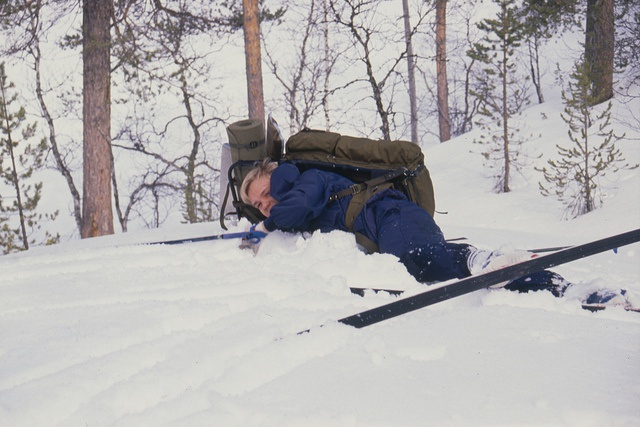Describe the objects in this image and their specific colors. I can see people in black, navy, lightgray, and gray tones, backpack in black and gray tones, and skis in black, lightgray, and gray tones in this image. 